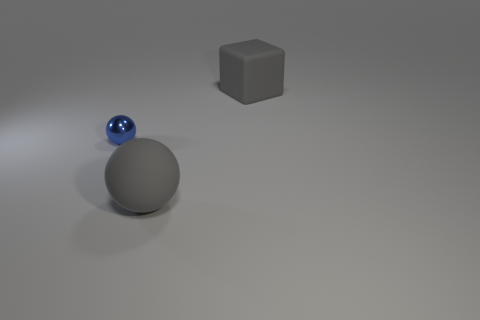Add 1 tiny yellow metallic cubes. How many objects exist? 4 Subtract 1 blue balls. How many objects are left? 2 Subtract all blocks. How many objects are left? 2 Subtract all blue cylinders. Subtract all blue things. How many objects are left? 2 Add 1 gray rubber spheres. How many gray rubber spheres are left? 2 Add 2 large brown metallic things. How many large brown metallic things exist? 2 